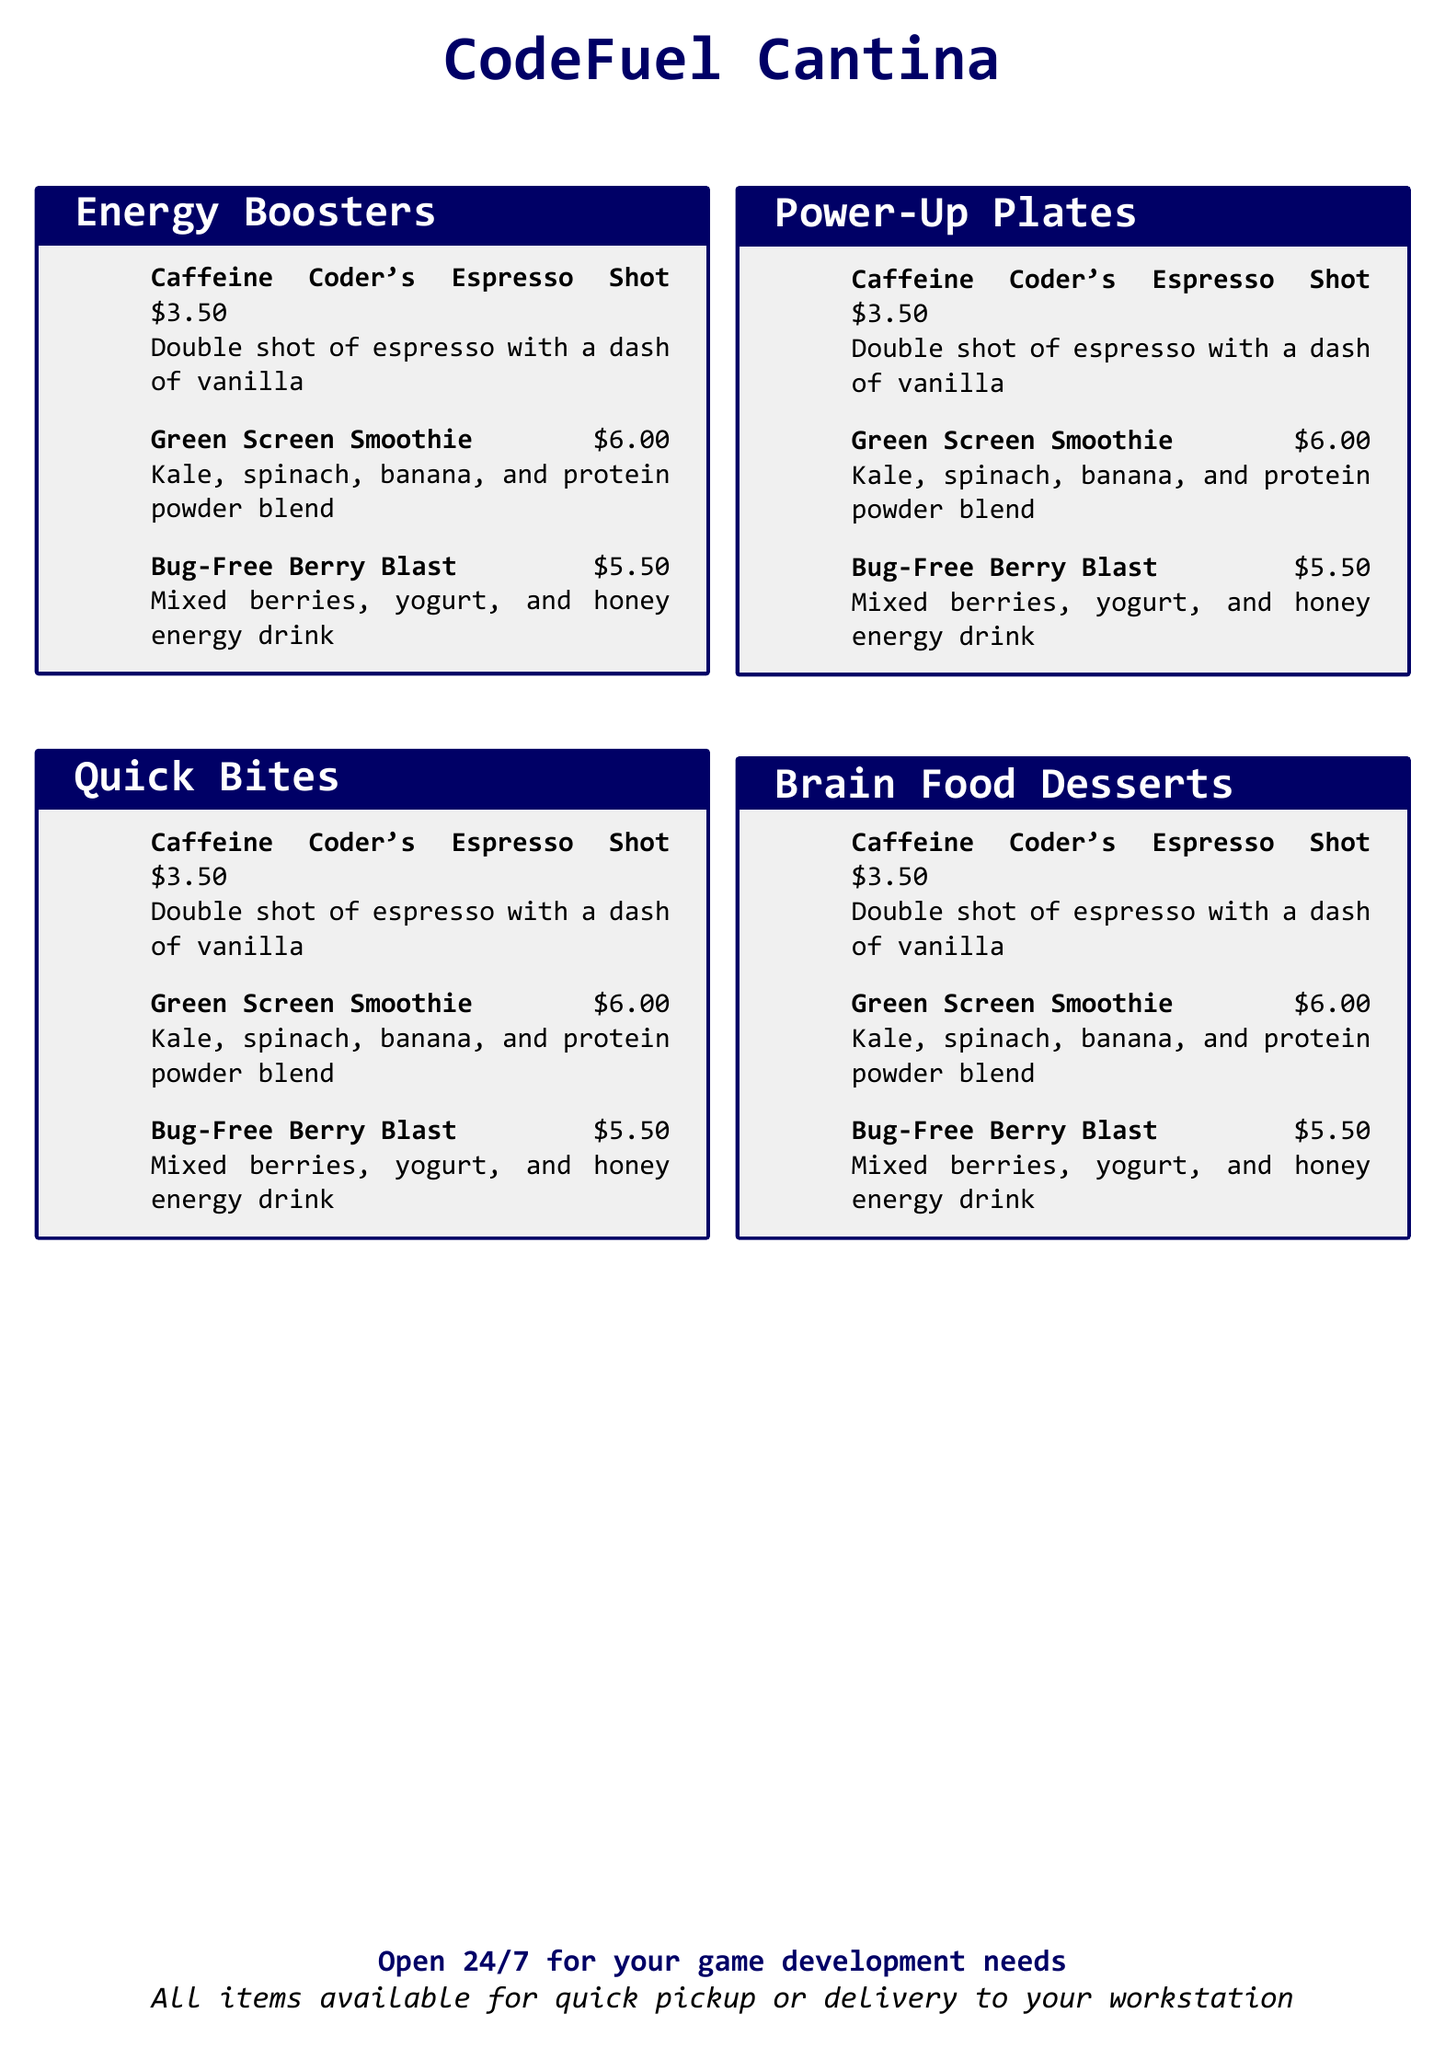What is the name of the cantina? The name of the cantina is prominently displayed at the top of the document.
Answer: CodeFuel Cantina How much does a Bug-Free Berry Blast cost? The price of the Bug-Free Berry Blast is listed next to its description.
Answer: $5.50 What main ingredient is in the Green Screen Smoothie? The description indicates the main ingredients of the Green Screen Smoothie with key items listed.
Answer: Kale How many drinks are listed under Energy Boosters? The number of drinks is determined by counting the items in the Energy Boosters section.
Answer: 3 What type of drink is the Caffeine Coder's Espresso Shot? The type of drink is specified directly in its name.
Answer: Espresso Are all items available for quick pickup? The document states a specific service availability regarding item pickup and delivery.
Answer: Yes What hour is the cantina open? The opening hours are indicated in the last section of the document.
Answer: 24/7 What is the primary theme of the menu? The overall theme is inferred from the titles of the sections as related to gaming and energy.
Answer: Game development What type of food items are included in Power-Up Plates? The document does not specify items under Power-Up Plates, but implies energy-related options.
Answer: Not listed 